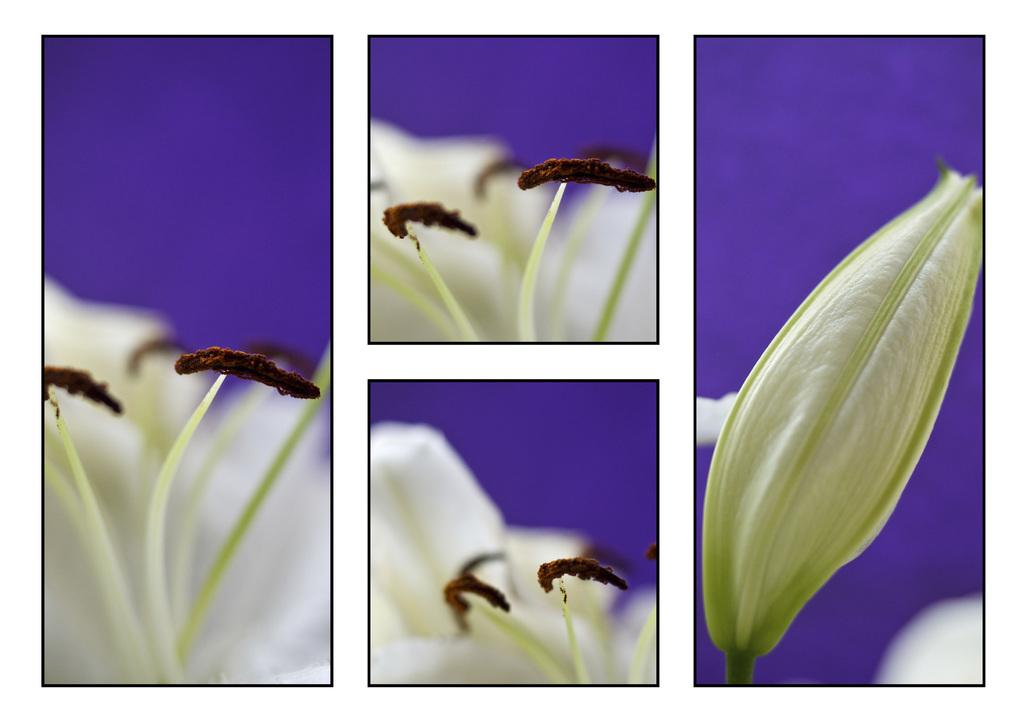What type of artwork is the image? The image is a collage. What type of flora can be seen in the image? There are flowers in the image. How would you describe the background of the image? The background of the image is blurred. What type of seed is used to grow the flowers in the image? There is no information about seeds in the image, as it only shows the flowers themselves. 